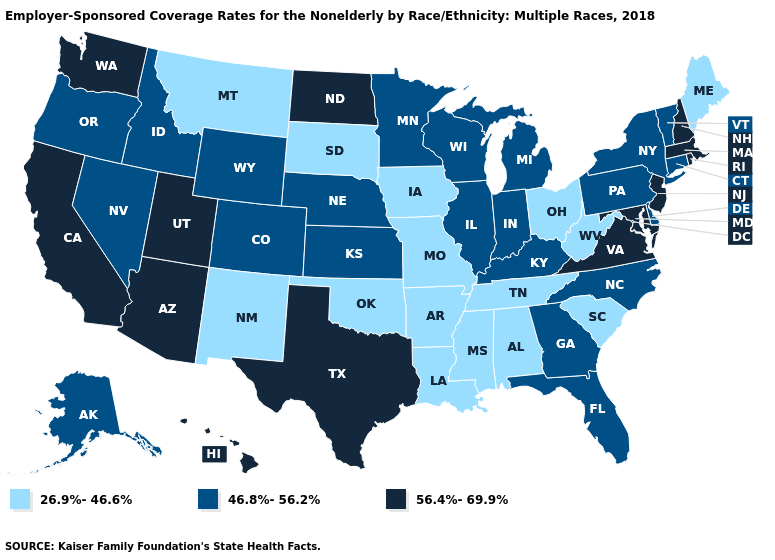Name the states that have a value in the range 26.9%-46.6%?
Be succinct. Alabama, Arkansas, Iowa, Louisiana, Maine, Mississippi, Missouri, Montana, New Mexico, Ohio, Oklahoma, South Carolina, South Dakota, Tennessee, West Virginia. What is the value of Minnesota?
Be succinct. 46.8%-56.2%. Does Idaho have the highest value in the West?
Be succinct. No. Among the states that border New Jersey , which have the highest value?
Be succinct. Delaware, New York, Pennsylvania. Does the map have missing data?
Quick response, please. No. Does the map have missing data?
Quick response, please. No. Does Utah have a higher value than Massachusetts?
Answer briefly. No. Does Tennessee have the lowest value in the USA?
Short answer required. Yes. How many symbols are there in the legend?
Keep it brief. 3. Name the states that have a value in the range 46.8%-56.2%?
Short answer required. Alaska, Colorado, Connecticut, Delaware, Florida, Georgia, Idaho, Illinois, Indiana, Kansas, Kentucky, Michigan, Minnesota, Nebraska, Nevada, New York, North Carolina, Oregon, Pennsylvania, Vermont, Wisconsin, Wyoming. Name the states that have a value in the range 46.8%-56.2%?
Short answer required. Alaska, Colorado, Connecticut, Delaware, Florida, Georgia, Idaho, Illinois, Indiana, Kansas, Kentucky, Michigan, Minnesota, Nebraska, Nevada, New York, North Carolina, Oregon, Pennsylvania, Vermont, Wisconsin, Wyoming. Name the states that have a value in the range 46.8%-56.2%?
Write a very short answer. Alaska, Colorado, Connecticut, Delaware, Florida, Georgia, Idaho, Illinois, Indiana, Kansas, Kentucky, Michigan, Minnesota, Nebraska, Nevada, New York, North Carolina, Oregon, Pennsylvania, Vermont, Wisconsin, Wyoming. Does the map have missing data?
Concise answer only. No. Among the states that border Pennsylvania , which have the lowest value?
Quick response, please. Ohio, West Virginia. Does Hawaii have the lowest value in the West?
Write a very short answer. No. 